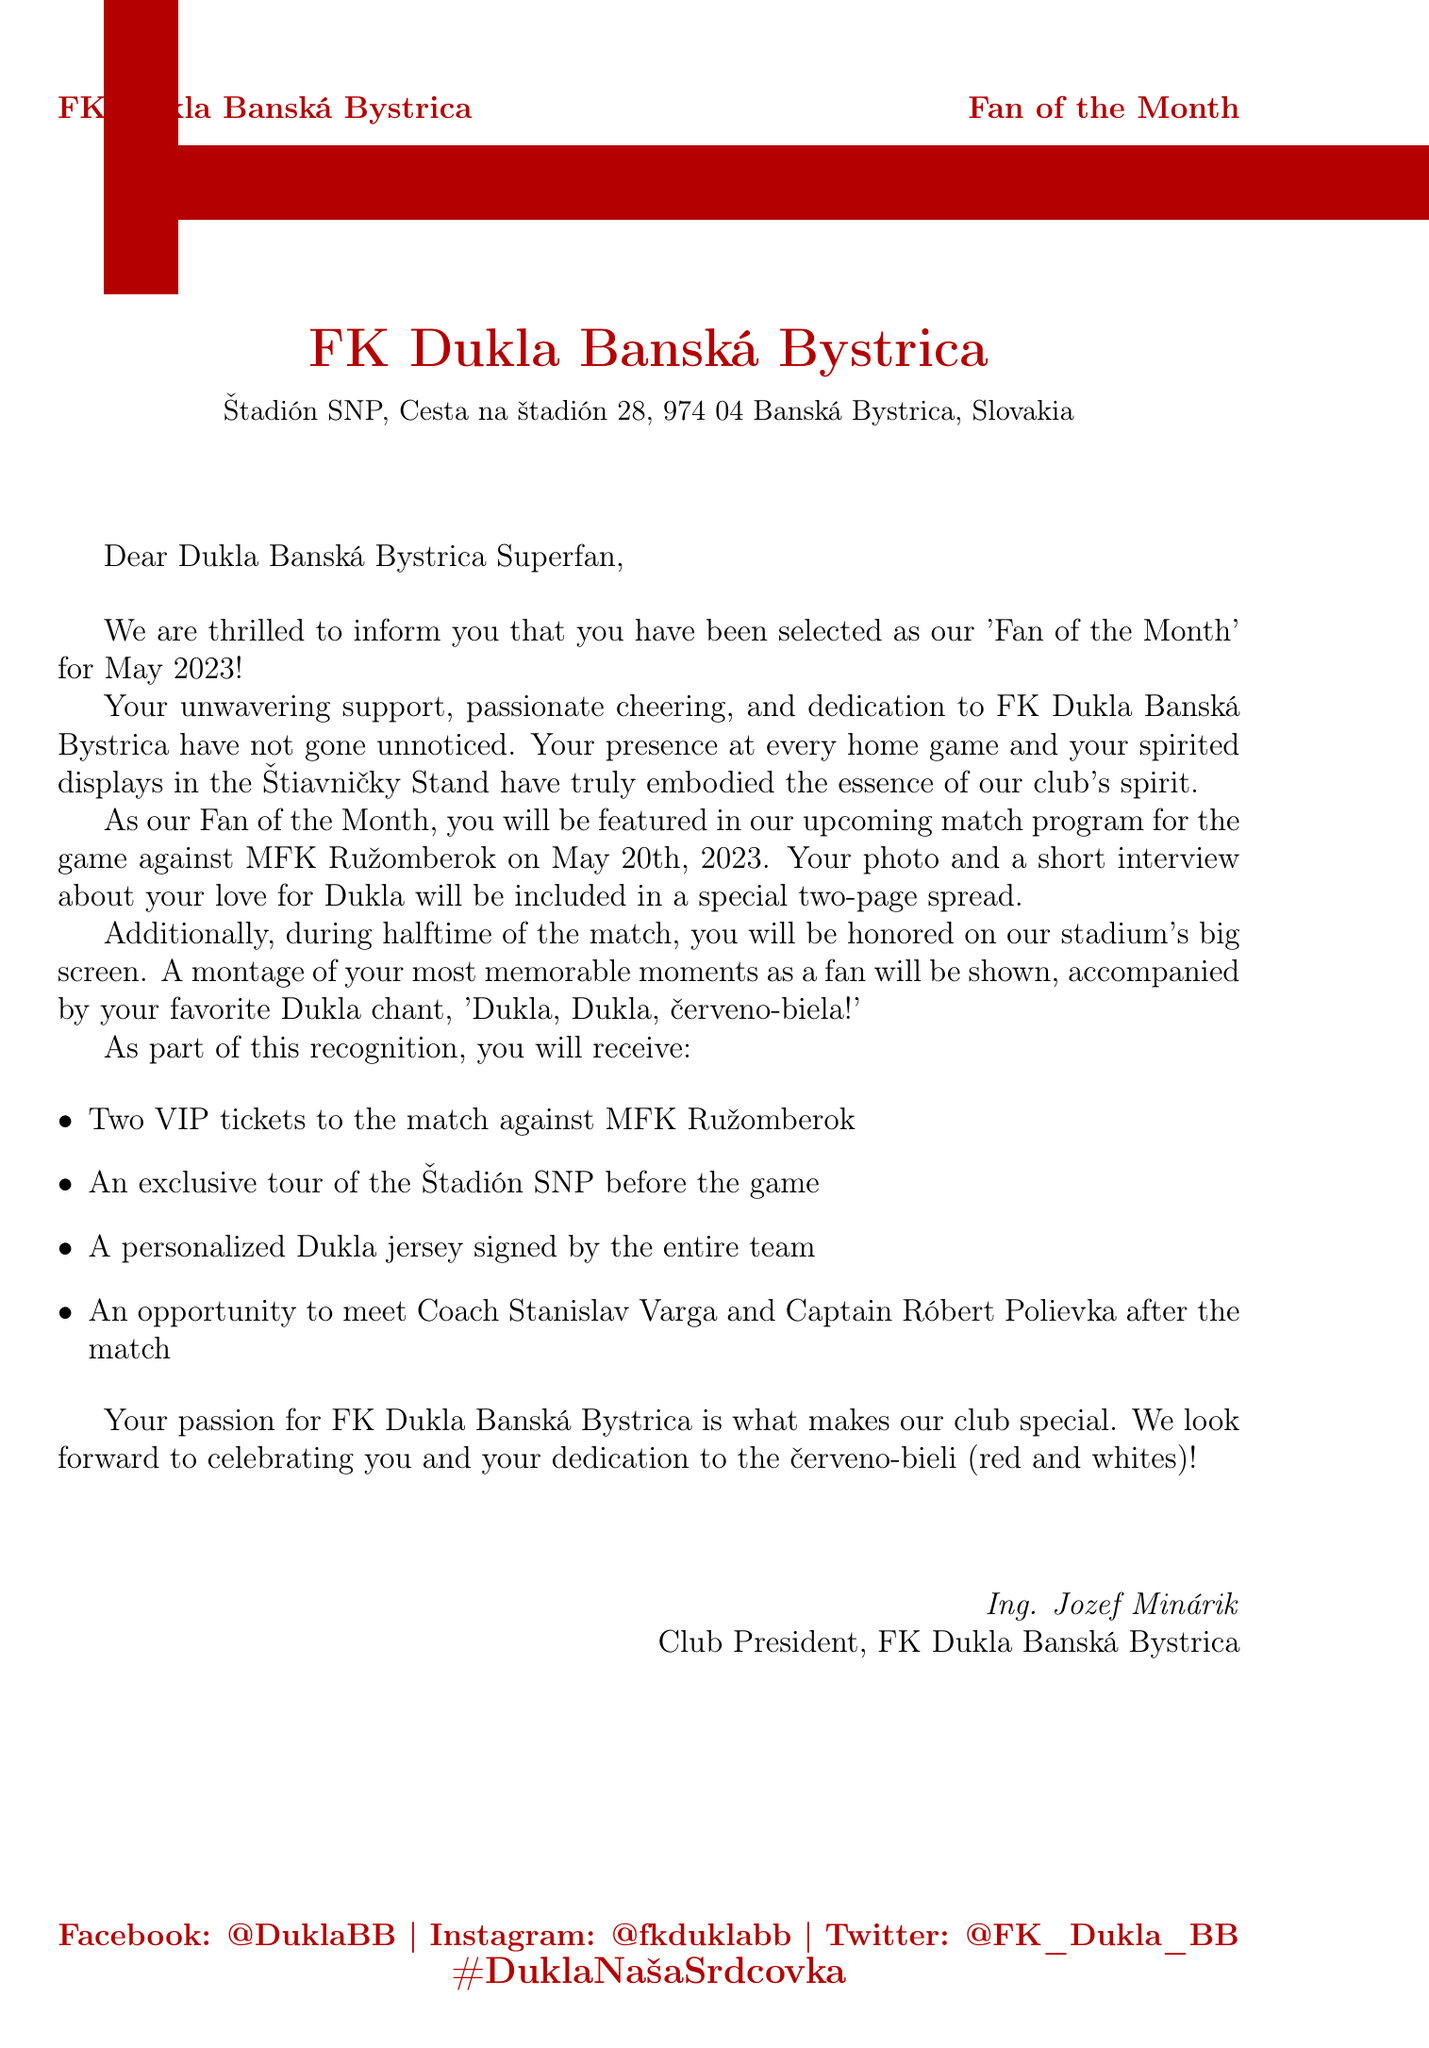What is the club's name? The club's name is presented at the top of the document in a bold format, indicating the identity of the organization.
Answer: FK Dukla Banská Bystrica When will the featured match take place? The date of the match is specified within the main content section, informing the fan when they will be recognized.
Answer: May 20th, 2023 Who will the match be against? The opponent in the match is mentioned alongside the date, providing information about the event.
Answer: MFK Ružomberok What is included in the two-page spread? The content specified states what the selected fan will have during the match program, detailing the recognition they will receive.
Answer: Photo and a short interview What chant will be featured during halftime? The chant is quoted in the document, showing the club's culture and what the fan will be celebrated with on the big screen.
Answer: Dukla, Dukla, červeno-biela! Who is the sender of the letter? The sender's name and position are clearly stated at the end of the document, identifying who is recognizing the fan.
Answer: Ing. Jozef Minárik What type of tickets will the fan receive? Different perks are listed, and one specifies the nature of the tickets provided to the selected fan.
Answer: VIP tickets What opportunity will the fan have after the match? This is noted among the perks and highlights a unique experience for the selected fan.
Answer: Meet Coach Stanislav Varga and Captain Róbert Polievka Which social media platforms are mentioned? Social media connections are laid out in the footer, indicating ways to engage with the club.
Answer: Facebook, Instagram, Twitter 